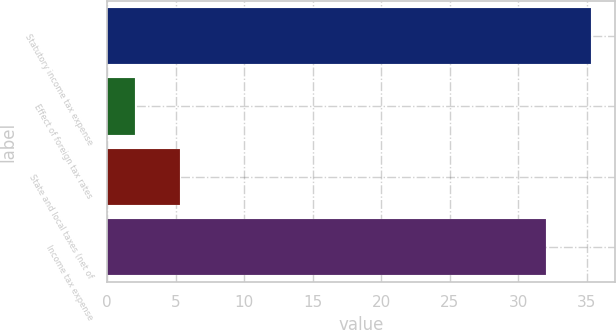Convert chart to OTSL. <chart><loc_0><loc_0><loc_500><loc_500><bar_chart><fcel>Statutory income tax expense<fcel>Effect of foreign tax rates<fcel>State and local taxes (net of<fcel>Income tax expense<nl><fcel>35.3<fcel>2<fcel>5.3<fcel>32<nl></chart> 